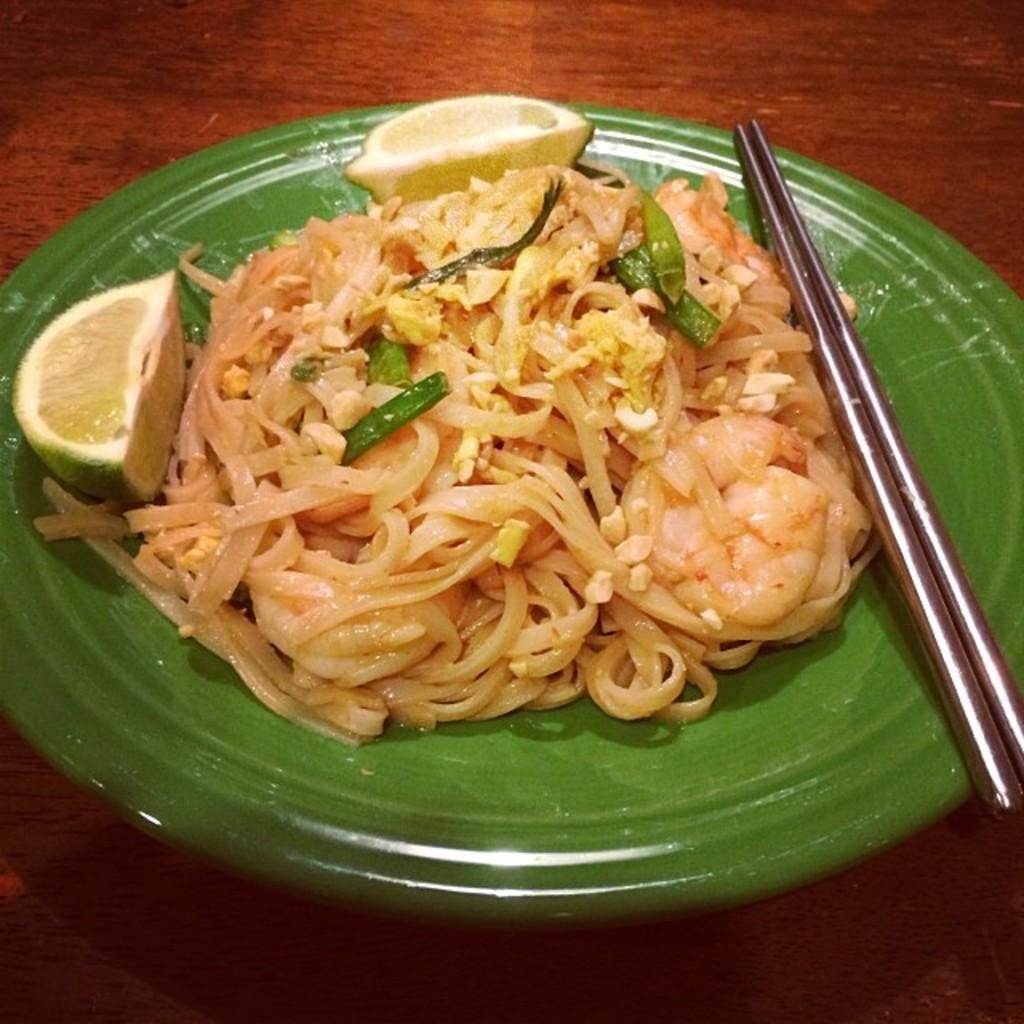What is placed on the plate in the image? There is a plate filled with food items in the image. Can you describe the food items on the plate? Unfortunately, the specific food items cannot be determined from the image alone. What might someone be about to do with the plate of food? Someone might be about to eat the food on the plate. What theory does the writer present in the image? There is no writer or theory present in the image; it features a plate filled with food items. 